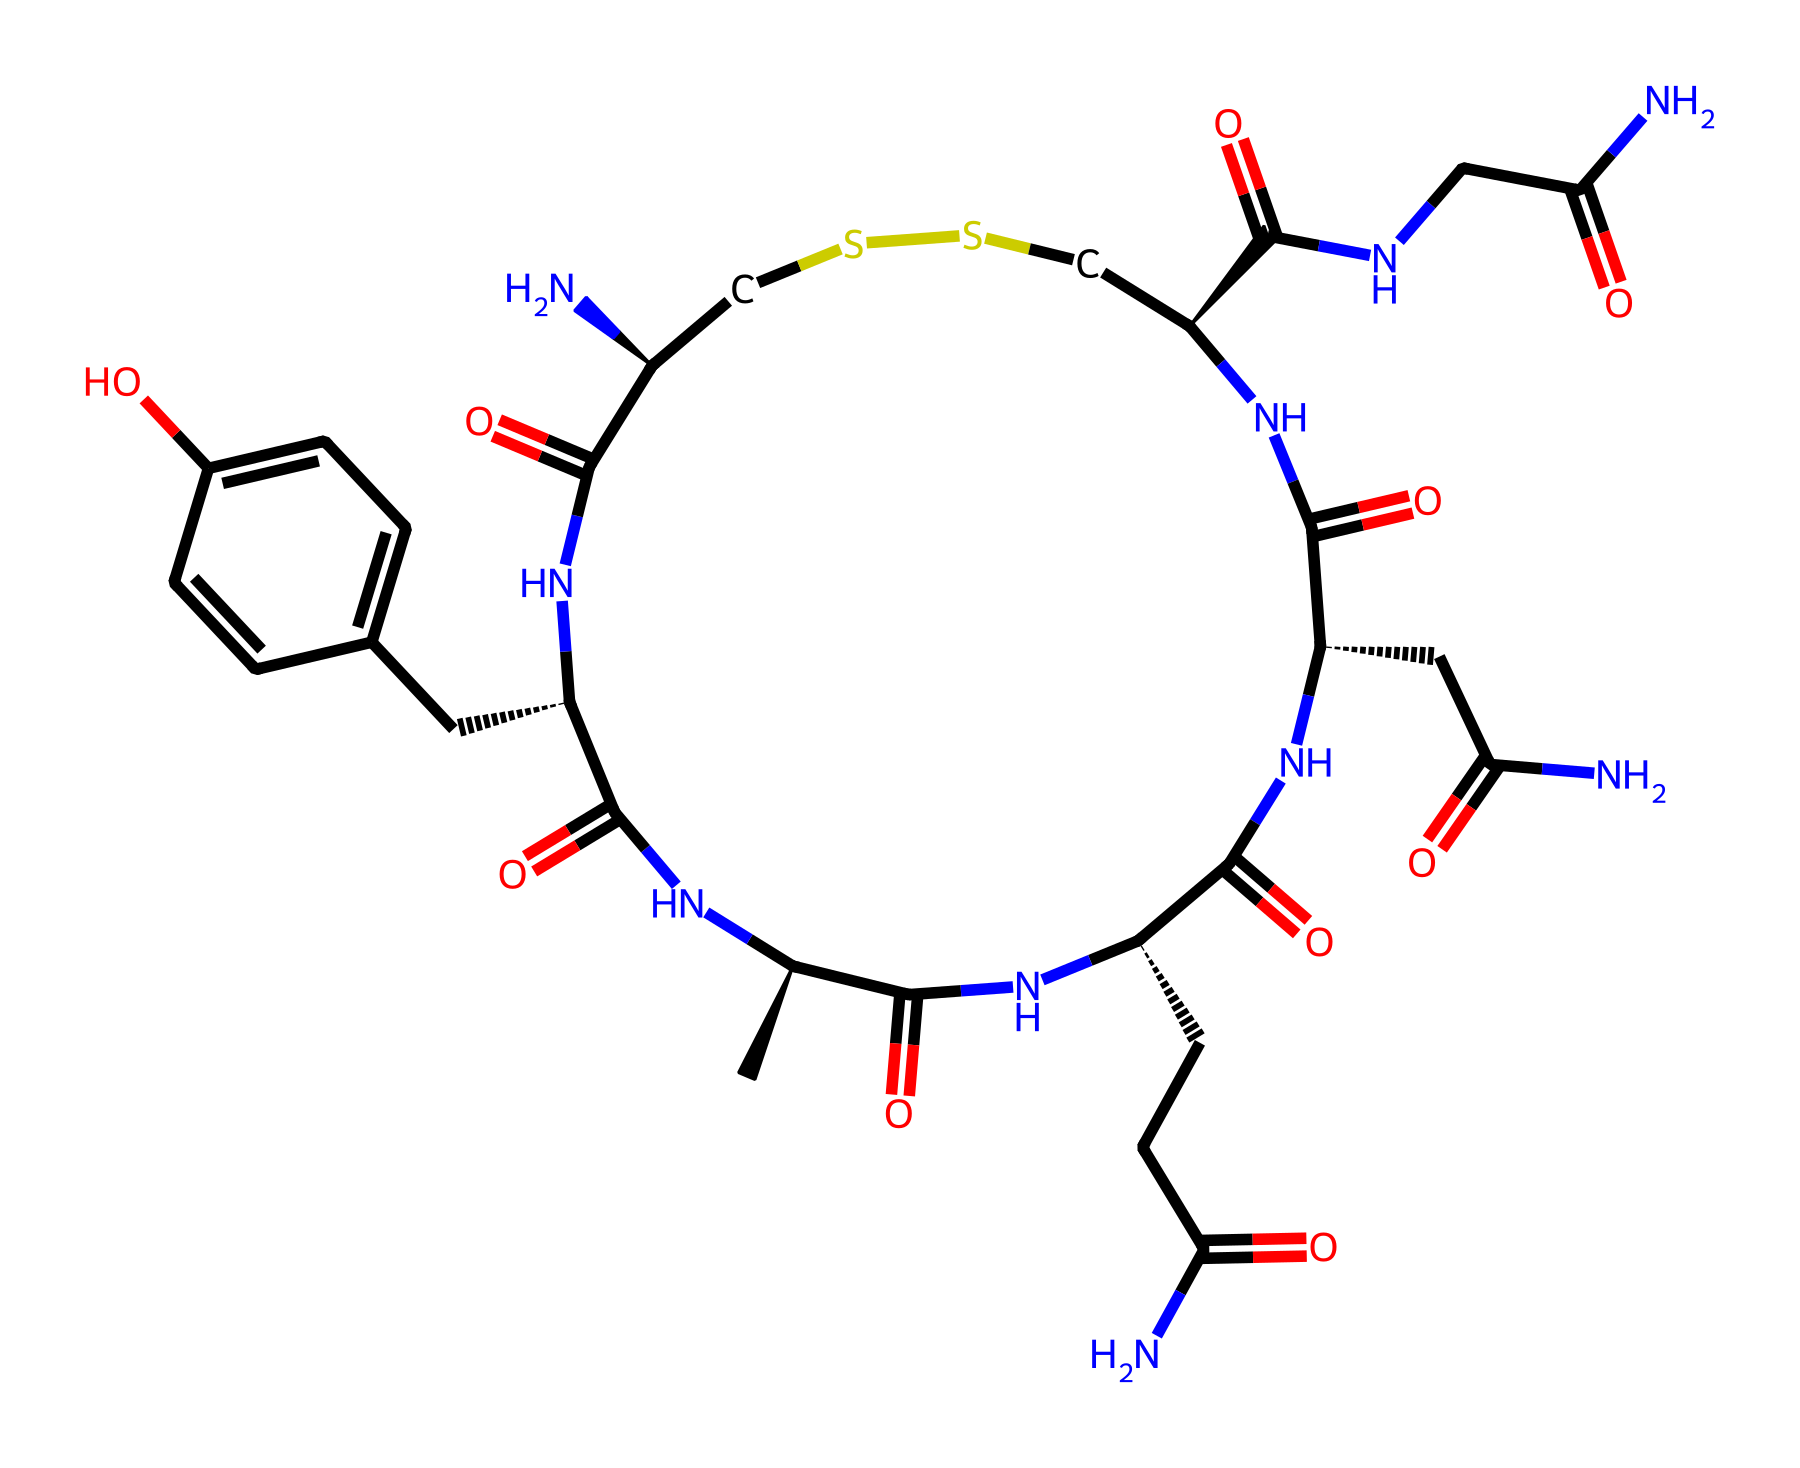What is the molecular weight of oxytocin? To find the molecular weight of a compound, we sum the atomic weights of all the atoms in its structure. Oxytocin consists of nitrogen, carbon, sulfur, and oxygen atoms. Counting these atoms and using their respective atomic weights, the total molecular weight is calculated.
Answer: 1007.19 g/mol How many nitrogen atoms are present in oxytocin? By examining the structure, we can count the number of nitrogen (N) atoms present. In the SMILES notation, several sections indicate the presence of nitrogen atoms. There are six identifiable nitrogen atoms in this structure.
Answer: 6 What functional groups are present in oxytocin? Analyzing the structure, we can identify several functional groups including amides (–CONH–) and disulfides (–S–S–). By interpreting the SMILES, we observe these functional groups repeated and connected throughout the molecule.
Answer: amide, disulfide Which part of the structure is responsible for oxytocin's role in social bonding? Oxytocin primarily exerts its effects through its receptor interactions, particularly in the brain regions associated with emotional bonding and social behaviors. The peptide nature of oxytocin, characterized by its cyclic arrangement and presence of specific amino acids, enables these interactions.
Answer: peptide nature How many carbon atoms are there in the oxytocin structure? By counting the carbon (C) atoms in the provided structure, each section marked with a ‘C’ can be surveyed. After careful counting, you will find a total of 29 carbon atoms in this molecule.
Answer: 29 What is the primary biological function of oxytocin? Oxytocin is well-known for its role in childbirth and lactation as well as in facilitating social bonding and attachment. Its release during emotional moments emphasizes its function in social interactions and bonding.
Answer: bonding 